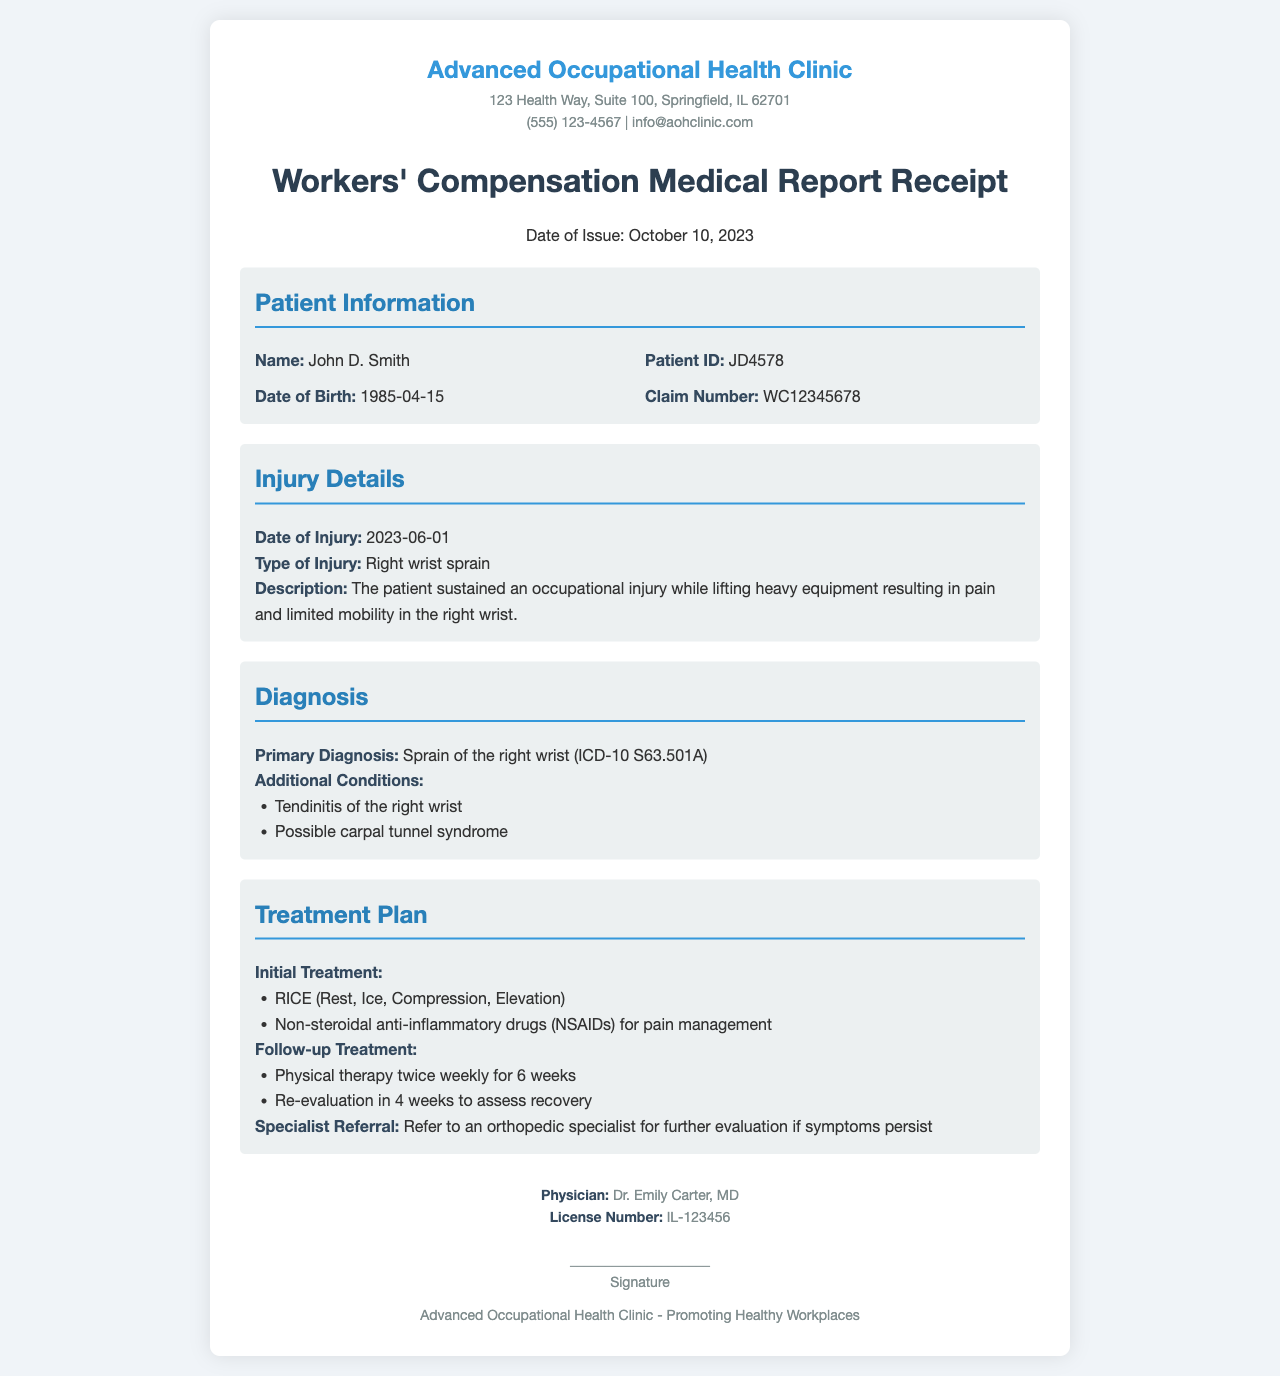what is the patient's name? The patient's name is listed at the beginning of the document in the Patient Information section.
Answer: John D. Smith when did the injury occur? The date of injury is specified in the Injury Details section.
Answer: 2023-06-01 what is the primary diagnosis? The primary diagnosis can be found in the Diagnosis section of the document.
Answer: Sprain of the right wrist (ICD-10 S63.501A) how many weeks of physical therapy are prescribed? The duration of physical therapy is mentioned in the Treatment Plan section.
Answer: 6 weeks what type of injury is reported? The type of injury is detailed in the Injury Details section of the document.
Answer: Right wrist sprain who is the treating physician? The physician's name is provided in the footer of the document.
Answer: Dr. Emily Carter, MD what is the patient ID? The patient ID can be found in the Patient Information section.
Answer: JD4578 what is the follow-up re-evaluation period? The follow-up treatment instructions include a specific period for re-evaluation in the Treatment Plan section.
Answer: 4 weeks what are the initial treatment recommendations? The initial treatment details are listed in the Treatment Plan section of the document.
Answer: RICE (Rest, Ice, Compression, Elevation) 